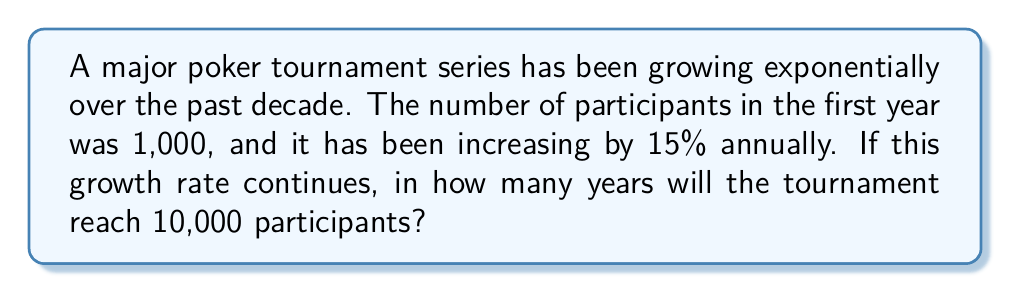Help me with this question. Let's approach this step-by-step using an exponential model and logarithms:

1) Let $P(t)$ be the number of participants after $t$ years, with $P(0) = 1000$.

2) The exponential growth model is:
   $P(t) = 1000 \cdot (1.15)^t$

3) We want to find $t$ when $P(t) = 10000$:
   $10000 = 1000 \cdot (1.15)^t$

4) Divide both sides by 1000:
   $10 = (1.15)^t$

5) Take the natural logarithm of both sides:
   $\ln(10) = \ln((1.15)^t)$

6) Use the logarithm property $\ln(a^b) = b\ln(a)$:
   $\ln(10) = t \cdot \ln(1.15)$

7) Solve for $t$:
   $t = \frac{\ln(10)}{\ln(1.15)}$

8) Calculate:
   $t \approx 16.58$ years

9) Since we need a whole number of years, we round up to 17 years.
Answer: 17 years 